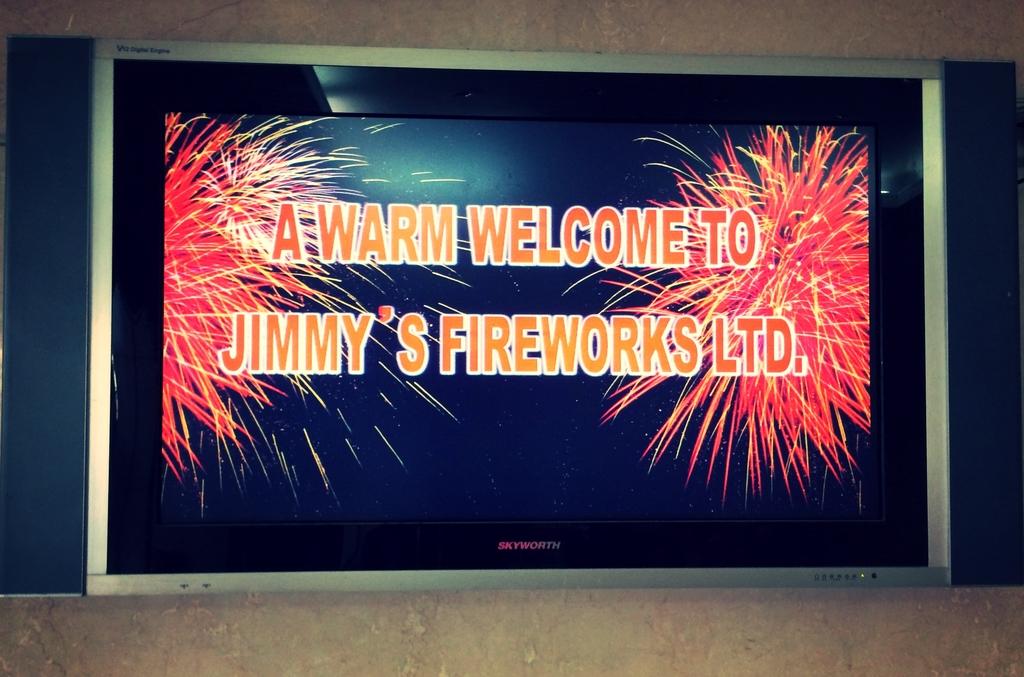Whose fireworks are listed?
Your answer should be compact. Jimmy's. What kind of welcome?
Give a very brief answer. Warm. 